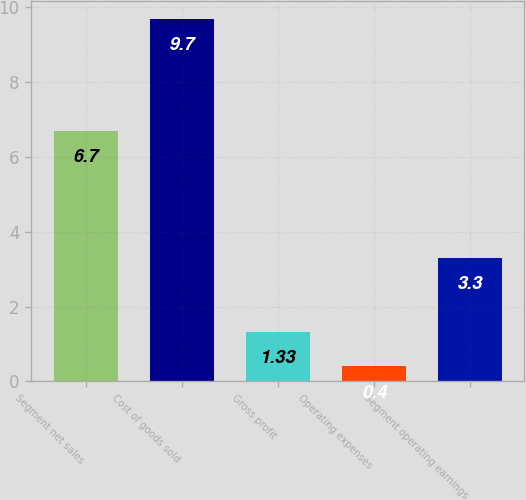Convert chart. <chart><loc_0><loc_0><loc_500><loc_500><bar_chart><fcel>Segment net sales<fcel>Cost of goods sold<fcel>Gross profit<fcel>Operating expenses<fcel>Segment operating earnings<nl><fcel>6.7<fcel>9.7<fcel>1.33<fcel>0.4<fcel>3.3<nl></chart> 